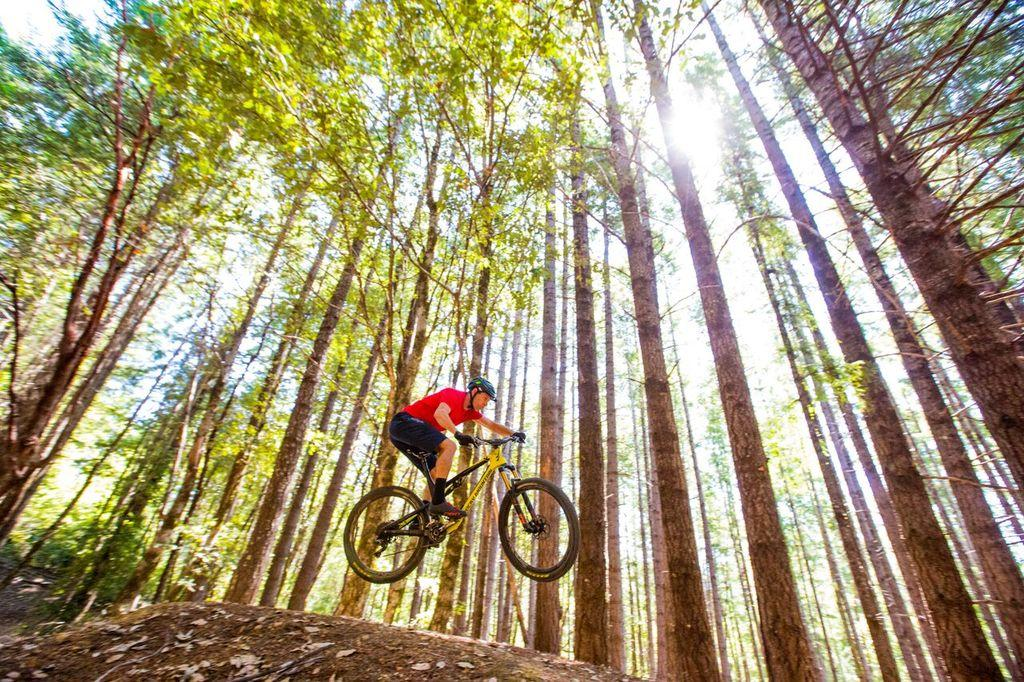What is the main subject of the image? There is a person riding a bicycle in the image. What is unique about the bicycle's position in the image? The bicycle is in the air. What can be seen beneath the bicycle? There is a path beneath the bicycle. What type of natural scenery is visible in the background of the image? There are trees in the background of the image. What verse is being recited by the person riding the bicycle in the image? There is no indication in the image that the person is reciting a verse, and therefore no such activity can be observed. 